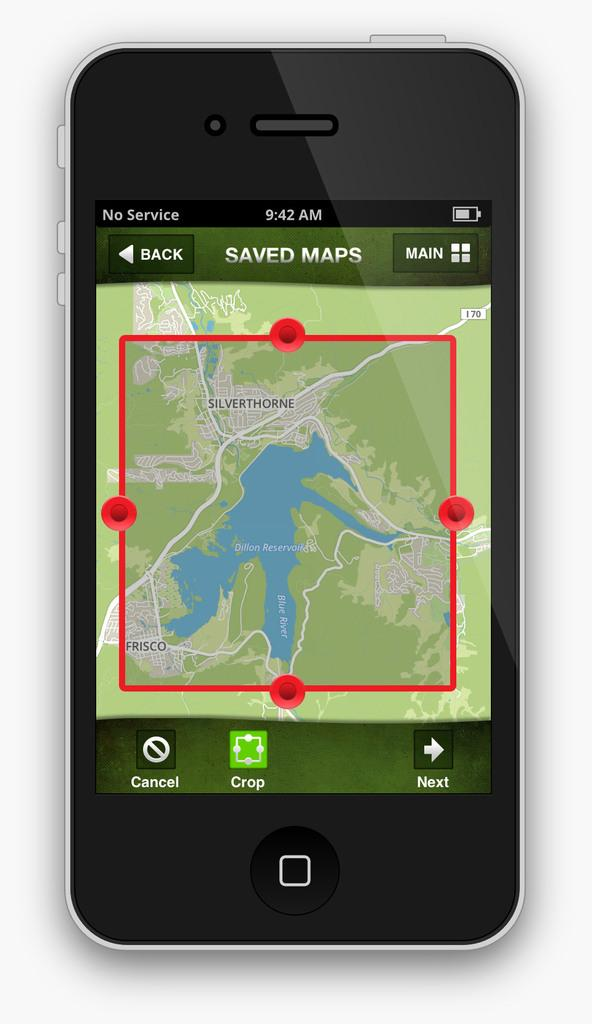<image>
Share a concise interpretation of the image provided. A map app on a smartphone that is on the Saved Maps screen. 